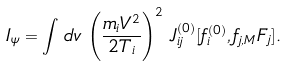<formula> <loc_0><loc_0><loc_500><loc_500>I _ { \psi } = \int \, d v \, \left ( \frac { m _ { i } V ^ { 2 } } { 2 T _ { i } } \right ) ^ { 2 } \, J _ { i j } ^ { ( 0 ) } [ f _ { i } ^ { ( 0 ) } , f _ { j , M } F _ { j } ] .</formula> 